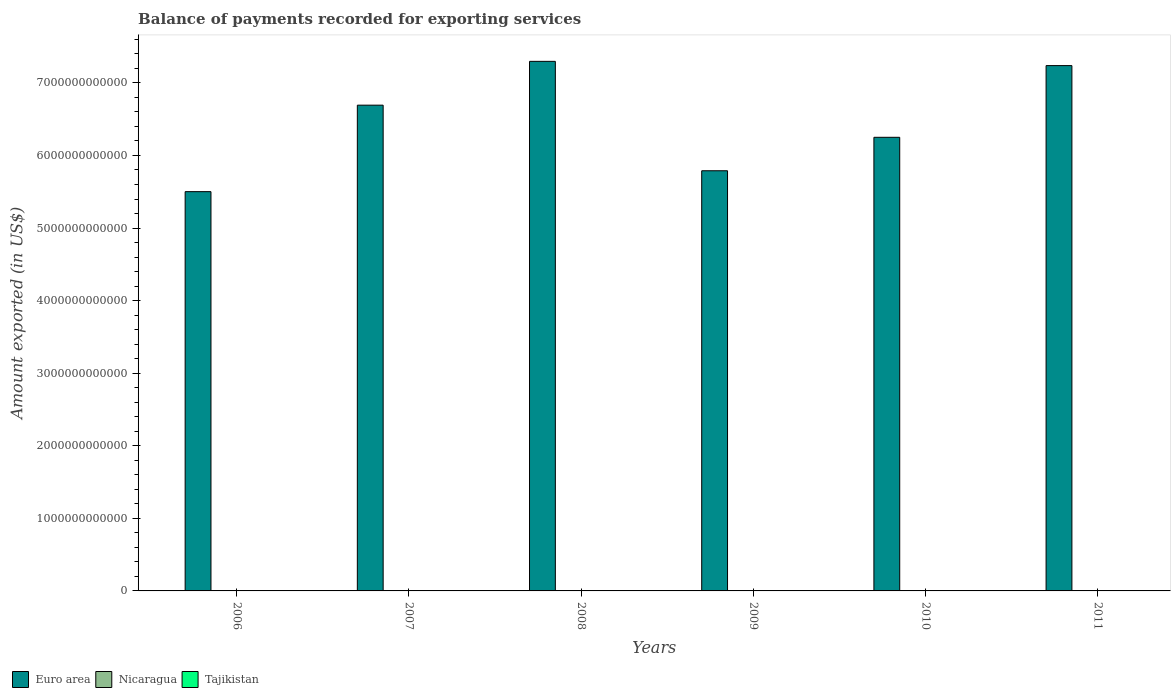How many bars are there on the 3rd tick from the left?
Offer a terse response. 3. How many bars are there on the 4th tick from the right?
Ensure brevity in your answer.  3. What is the label of the 4th group of bars from the left?
Your answer should be compact. 2009. What is the amount exported in Nicaragua in 2007?
Your response must be concise. 2.47e+09. Across all years, what is the maximum amount exported in Nicaragua?
Provide a short and direct response. 4.19e+09. Across all years, what is the minimum amount exported in Nicaragua?
Your response must be concise. 2.10e+09. In which year was the amount exported in Nicaragua maximum?
Your answer should be very brief. 2011. What is the total amount exported in Nicaragua in the graph?
Ensure brevity in your answer.  1.79e+1. What is the difference between the amount exported in Tajikistan in 2006 and that in 2010?
Provide a short and direct response. 7.59e+08. What is the difference between the amount exported in Euro area in 2011 and the amount exported in Tajikistan in 2007?
Give a very brief answer. 7.24e+12. What is the average amount exported in Nicaragua per year?
Provide a succinct answer. 2.98e+09. In the year 2007, what is the difference between the amount exported in Tajikistan and amount exported in Euro area?
Your answer should be compact. -6.69e+12. In how many years, is the amount exported in Nicaragua greater than 3200000000000 US$?
Provide a short and direct response. 0. What is the ratio of the amount exported in Tajikistan in 2006 to that in 2011?
Offer a terse response. 1.38. Is the amount exported in Euro area in 2009 less than that in 2011?
Provide a succinct answer. Yes. What is the difference between the highest and the second highest amount exported in Tajikistan?
Make the answer very short. 4.81e+07. What is the difference between the highest and the lowest amount exported in Tajikistan?
Ensure brevity in your answer.  8.77e+08. Is the sum of the amount exported in Nicaragua in 2007 and 2010 greater than the maximum amount exported in Euro area across all years?
Offer a terse response. No. What does the 2nd bar from the left in 2009 represents?
Offer a very short reply. Nicaragua. What does the 2nd bar from the right in 2010 represents?
Offer a very short reply. Nicaragua. How many bars are there?
Provide a short and direct response. 18. Are all the bars in the graph horizontal?
Ensure brevity in your answer.  No. What is the difference between two consecutive major ticks on the Y-axis?
Your answer should be compact. 1.00e+12. Does the graph contain any zero values?
Your response must be concise. No. Does the graph contain grids?
Provide a short and direct response. No. How many legend labels are there?
Provide a short and direct response. 3. How are the legend labels stacked?
Your answer should be compact. Horizontal. What is the title of the graph?
Your response must be concise. Balance of payments recorded for exporting services. What is the label or title of the X-axis?
Your response must be concise. Years. What is the label or title of the Y-axis?
Give a very brief answer. Amount exported (in US$). What is the Amount exported (in US$) in Euro area in 2006?
Give a very brief answer. 5.50e+12. What is the Amount exported (in US$) in Nicaragua in 2006?
Offer a very short reply. 2.10e+09. What is the Amount exported (in US$) in Tajikistan in 2006?
Make the answer very short. 1.66e+09. What is the Amount exported (in US$) in Euro area in 2007?
Offer a very short reply. 6.69e+12. What is the Amount exported (in US$) of Nicaragua in 2007?
Provide a succinct answer. 2.47e+09. What is the Amount exported (in US$) in Tajikistan in 2007?
Your response must be concise. 1.73e+09. What is the Amount exported (in US$) of Euro area in 2008?
Ensure brevity in your answer.  7.30e+12. What is the Amount exported (in US$) in Nicaragua in 2008?
Keep it short and to the point. 2.88e+09. What is the Amount exported (in US$) of Tajikistan in 2008?
Offer a terse response. 1.78e+09. What is the Amount exported (in US$) of Euro area in 2009?
Keep it short and to the point. 5.79e+12. What is the Amount exported (in US$) of Nicaragua in 2009?
Your answer should be compact. 2.84e+09. What is the Amount exported (in US$) in Tajikistan in 2009?
Provide a succinct answer. 1.23e+09. What is the Amount exported (in US$) in Euro area in 2010?
Offer a terse response. 6.25e+12. What is the Amount exported (in US$) of Nicaragua in 2010?
Give a very brief answer. 3.38e+09. What is the Amount exported (in US$) in Tajikistan in 2010?
Your response must be concise. 8.99e+08. What is the Amount exported (in US$) of Euro area in 2011?
Offer a terse response. 7.24e+12. What is the Amount exported (in US$) in Nicaragua in 2011?
Offer a very short reply. 4.19e+09. What is the Amount exported (in US$) in Tajikistan in 2011?
Your answer should be very brief. 1.20e+09. Across all years, what is the maximum Amount exported (in US$) of Euro area?
Your answer should be compact. 7.30e+12. Across all years, what is the maximum Amount exported (in US$) in Nicaragua?
Keep it short and to the point. 4.19e+09. Across all years, what is the maximum Amount exported (in US$) in Tajikistan?
Give a very brief answer. 1.78e+09. Across all years, what is the minimum Amount exported (in US$) in Euro area?
Offer a terse response. 5.50e+12. Across all years, what is the minimum Amount exported (in US$) in Nicaragua?
Keep it short and to the point. 2.10e+09. Across all years, what is the minimum Amount exported (in US$) in Tajikistan?
Give a very brief answer. 8.99e+08. What is the total Amount exported (in US$) in Euro area in the graph?
Give a very brief answer. 3.88e+13. What is the total Amount exported (in US$) in Nicaragua in the graph?
Your answer should be compact. 1.79e+1. What is the total Amount exported (in US$) of Tajikistan in the graph?
Your answer should be compact. 8.49e+09. What is the difference between the Amount exported (in US$) of Euro area in 2006 and that in 2007?
Provide a succinct answer. -1.19e+12. What is the difference between the Amount exported (in US$) of Nicaragua in 2006 and that in 2007?
Your answer should be compact. -3.72e+08. What is the difference between the Amount exported (in US$) in Tajikistan in 2006 and that in 2007?
Your response must be concise. -6.96e+07. What is the difference between the Amount exported (in US$) of Euro area in 2006 and that in 2008?
Your response must be concise. -1.80e+12. What is the difference between the Amount exported (in US$) in Nicaragua in 2006 and that in 2008?
Your answer should be compact. -7.79e+08. What is the difference between the Amount exported (in US$) of Tajikistan in 2006 and that in 2008?
Keep it short and to the point. -1.18e+08. What is the difference between the Amount exported (in US$) in Euro area in 2006 and that in 2009?
Your answer should be very brief. -2.88e+11. What is the difference between the Amount exported (in US$) of Nicaragua in 2006 and that in 2009?
Provide a short and direct response. -7.42e+08. What is the difference between the Amount exported (in US$) in Tajikistan in 2006 and that in 2009?
Ensure brevity in your answer.  4.33e+08. What is the difference between the Amount exported (in US$) of Euro area in 2006 and that in 2010?
Your response must be concise. -7.49e+11. What is the difference between the Amount exported (in US$) in Nicaragua in 2006 and that in 2010?
Offer a very short reply. -1.28e+09. What is the difference between the Amount exported (in US$) of Tajikistan in 2006 and that in 2010?
Provide a short and direct response. 7.59e+08. What is the difference between the Amount exported (in US$) of Euro area in 2006 and that in 2011?
Your answer should be compact. -1.74e+12. What is the difference between the Amount exported (in US$) in Nicaragua in 2006 and that in 2011?
Offer a very short reply. -2.09e+09. What is the difference between the Amount exported (in US$) in Tajikistan in 2006 and that in 2011?
Ensure brevity in your answer.  4.60e+08. What is the difference between the Amount exported (in US$) of Euro area in 2007 and that in 2008?
Your response must be concise. -6.04e+11. What is the difference between the Amount exported (in US$) of Nicaragua in 2007 and that in 2008?
Provide a short and direct response. -4.07e+08. What is the difference between the Amount exported (in US$) in Tajikistan in 2007 and that in 2008?
Provide a succinct answer. -4.81e+07. What is the difference between the Amount exported (in US$) in Euro area in 2007 and that in 2009?
Make the answer very short. 9.04e+11. What is the difference between the Amount exported (in US$) of Nicaragua in 2007 and that in 2009?
Provide a succinct answer. -3.69e+08. What is the difference between the Amount exported (in US$) in Tajikistan in 2007 and that in 2009?
Ensure brevity in your answer.  5.03e+08. What is the difference between the Amount exported (in US$) of Euro area in 2007 and that in 2010?
Give a very brief answer. 4.43e+11. What is the difference between the Amount exported (in US$) of Nicaragua in 2007 and that in 2010?
Keep it short and to the point. -9.09e+08. What is the difference between the Amount exported (in US$) in Tajikistan in 2007 and that in 2010?
Your response must be concise. 8.29e+08. What is the difference between the Amount exported (in US$) of Euro area in 2007 and that in 2011?
Provide a short and direct response. -5.45e+11. What is the difference between the Amount exported (in US$) of Nicaragua in 2007 and that in 2011?
Provide a short and direct response. -1.72e+09. What is the difference between the Amount exported (in US$) of Tajikistan in 2007 and that in 2011?
Your answer should be compact. 5.30e+08. What is the difference between the Amount exported (in US$) of Euro area in 2008 and that in 2009?
Keep it short and to the point. 1.51e+12. What is the difference between the Amount exported (in US$) of Nicaragua in 2008 and that in 2009?
Ensure brevity in your answer.  3.75e+07. What is the difference between the Amount exported (in US$) in Tajikistan in 2008 and that in 2009?
Offer a very short reply. 5.51e+08. What is the difference between the Amount exported (in US$) of Euro area in 2008 and that in 2010?
Provide a succinct answer. 1.05e+12. What is the difference between the Amount exported (in US$) of Nicaragua in 2008 and that in 2010?
Keep it short and to the point. -5.02e+08. What is the difference between the Amount exported (in US$) of Tajikistan in 2008 and that in 2010?
Your answer should be very brief. 8.77e+08. What is the difference between the Amount exported (in US$) in Euro area in 2008 and that in 2011?
Ensure brevity in your answer.  5.84e+1. What is the difference between the Amount exported (in US$) in Nicaragua in 2008 and that in 2011?
Ensure brevity in your answer.  -1.32e+09. What is the difference between the Amount exported (in US$) of Tajikistan in 2008 and that in 2011?
Provide a succinct answer. 5.78e+08. What is the difference between the Amount exported (in US$) in Euro area in 2009 and that in 2010?
Your response must be concise. -4.61e+11. What is the difference between the Amount exported (in US$) in Nicaragua in 2009 and that in 2010?
Your answer should be very brief. -5.40e+08. What is the difference between the Amount exported (in US$) of Tajikistan in 2009 and that in 2010?
Your answer should be very brief. 3.26e+08. What is the difference between the Amount exported (in US$) in Euro area in 2009 and that in 2011?
Provide a short and direct response. -1.45e+12. What is the difference between the Amount exported (in US$) of Nicaragua in 2009 and that in 2011?
Your answer should be very brief. -1.35e+09. What is the difference between the Amount exported (in US$) of Tajikistan in 2009 and that in 2011?
Offer a very short reply. 2.75e+07. What is the difference between the Amount exported (in US$) in Euro area in 2010 and that in 2011?
Provide a succinct answer. -9.88e+11. What is the difference between the Amount exported (in US$) of Nicaragua in 2010 and that in 2011?
Provide a short and direct response. -8.13e+08. What is the difference between the Amount exported (in US$) in Tajikistan in 2010 and that in 2011?
Keep it short and to the point. -2.99e+08. What is the difference between the Amount exported (in US$) of Euro area in 2006 and the Amount exported (in US$) of Nicaragua in 2007?
Provide a succinct answer. 5.50e+12. What is the difference between the Amount exported (in US$) in Euro area in 2006 and the Amount exported (in US$) in Tajikistan in 2007?
Make the answer very short. 5.50e+12. What is the difference between the Amount exported (in US$) of Nicaragua in 2006 and the Amount exported (in US$) of Tajikistan in 2007?
Keep it short and to the point. 3.69e+08. What is the difference between the Amount exported (in US$) of Euro area in 2006 and the Amount exported (in US$) of Nicaragua in 2008?
Your response must be concise. 5.50e+12. What is the difference between the Amount exported (in US$) in Euro area in 2006 and the Amount exported (in US$) in Tajikistan in 2008?
Offer a terse response. 5.50e+12. What is the difference between the Amount exported (in US$) in Nicaragua in 2006 and the Amount exported (in US$) in Tajikistan in 2008?
Your answer should be very brief. 3.20e+08. What is the difference between the Amount exported (in US$) of Euro area in 2006 and the Amount exported (in US$) of Nicaragua in 2009?
Provide a succinct answer. 5.50e+12. What is the difference between the Amount exported (in US$) in Euro area in 2006 and the Amount exported (in US$) in Tajikistan in 2009?
Your answer should be compact. 5.50e+12. What is the difference between the Amount exported (in US$) of Nicaragua in 2006 and the Amount exported (in US$) of Tajikistan in 2009?
Offer a very short reply. 8.71e+08. What is the difference between the Amount exported (in US$) in Euro area in 2006 and the Amount exported (in US$) in Nicaragua in 2010?
Offer a terse response. 5.50e+12. What is the difference between the Amount exported (in US$) of Euro area in 2006 and the Amount exported (in US$) of Tajikistan in 2010?
Your answer should be compact. 5.50e+12. What is the difference between the Amount exported (in US$) of Nicaragua in 2006 and the Amount exported (in US$) of Tajikistan in 2010?
Give a very brief answer. 1.20e+09. What is the difference between the Amount exported (in US$) of Euro area in 2006 and the Amount exported (in US$) of Nicaragua in 2011?
Make the answer very short. 5.50e+12. What is the difference between the Amount exported (in US$) in Euro area in 2006 and the Amount exported (in US$) in Tajikistan in 2011?
Offer a terse response. 5.50e+12. What is the difference between the Amount exported (in US$) of Nicaragua in 2006 and the Amount exported (in US$) of Tajikistan in 2011?
Provide a succinct answer. 8.99e+08. What is the difference between the Amount exported (in US$) in Euro area in 2007 and the Amount exported (in US$) in Nicaragua in 2008?
Provide a succinct answer. 6.69e+12. What is the difference between the Amount exported (in US$) in Euro area in 2007 and the Amount exported (in US$) in Tajikistan in 2008?
Keep it short and to the point. 6.69e+12. What is the difference between the Amount exported (in US$) of Nicaragua in 2007 and the Amount exported (in US$) of Tajikistan in 2008?
Keep it short and to the point. 6.93e+08. What is the difference between the Amount exported (in US$) in Euro area in 2007 and the Amount exported (in US$) in Nicaragua in 2009?
Keep it short and to the point. 6.69e+12. What is the difference between the Amount exported (in US$) of Euro area in 2007 and the Amount exported (in US$) of Tajikistan in 2009?
Provide a succinct answer. 6.69e+12. What is the difference between the Amount exported (in US$) in Nicaragua in 2007 and the Amount exported (in US$) in Tajikistan in 2009?
Your answer should be very brief. 1.24e+09. What is the difference between the Amount exported (in US$) in Euro area in 2007 and the Amount exported (in US$) in Nicaragua in 2010?
Your answer should be very brief. 6.69e+12. What is the difference between the Amount exported (in US$) in Euro area in 2007 and the Amount exported (in US$) in Tajikistan in 2010?
Ensure brevity in your answer.  6.69e+12. What is the difference between the Amount exported (in US$) in Nicaragua in 2007 and the Amount exported (in US$) in Tajikistan in 2010?
Make the answer very short. 1.57e+09. What is the difference between the Amount exported (in US$) of Euro area in 2007 and the Amount exported (in US$) of Nicaragua in 2011?
Keep it short and to the point. 6.69e+12. What is the difference between the Amount exported (in US$) in Euro area in 2007 and the Amount exported (in US$) in Tajikistan in 2011?
Offer a very short reply. 6.69e+12. What is the difference between the Amount exported (in US$) of Nicaragua in 2007 and the Amount exported (in US$) of Tajikistan in 2011?
Your response must be concise. 1.27e+09. What is the difference between the Amount exported (in US$) of Euro area in 2008 and the Amount exported (in US$) of Nicaragua in 2009?
Your response must be concise. 7.29e+12. What is the difference between the Amount exported (in US$) in Euro area in 2008 and the Amount exported (in US$) in Tajikistan in 2009?
Provide a short and direct response. 7.30e+12. What is the difference between the Amount exported (in US$) in Nicaragua in 2008 and the Amount exported (in US$) in Tajikistan in 2009?
Provide a short and direct response. 1.65e+09. What is the difference between the Amount exported (in US$) in Euro area in 2008 and the Amount exported (in US$) in Nicaragua in 2010?
Provide a succinct answer. 7.29e+12. What is the difference between the Amount exported (in US$) in Euro area in 2008 and the Amount exported (in US$) in Tajikistan in 2010?
Give a very brief answer. 7.30e+12. What is the difference between the Amount exported (in US$) in Nicaragua in 2008 and the Amount exported (in US$) in Tajikistan in 2010?
Provide a succinct answer. 1.98e+09. What is the difference between the Amount exported (in US$) of Euro area in 2008 and the Amount exported (in US$) of Nicaragua in 2011?
Offer a very short reply. 7.29e+12. What is the difference between the Amount exported (in US$) in Euro area in 2008 and the Amount exported (in US$) in Tajikistan in 2011?
Your answer should be compact. 7.30e+12. What is the difference between the Amount exported (in US$) of Nicaragua in 2008 and the Amount exported (in US$) of Tajikistan in 2011?
Offer a very short reply. 1.68e+09. What is the difference between the Amount exported (in US$) in Euro area in 2009 and the Amount exported (in US$) in Nicaragua in 2010?
Ensure brevity in your answer.  5.79e+12. What is the difference between the Amount exported (in US$) of Euro area in 2009 and the Amount exported (in US$) of Tajikistan in 2010?
Keep it short and to the point. 5.79e+12. What is the difference between the Amount exported (in US$) in Nicaragua in 2009 and the Amount exported (in US$) in Tajikistan in 2010?
Make the answer very short. 1.94e+09. What is the difference between the Amount exported (in US$) in Euro area in 2009 and the Amount exported (in US$) in Nicaragua in 2011?
Give a very brief answer. 5.79e+12. What is the difference between the Amount exported (in US$) in Euro area in 2009 and the Amount exported (in US$) in Tajikistan in 2011?
Offer a terse response. 5.79e+12. What is the difference between the Amount exported (in US$) of Nicaragua in 2009 and the Amount exported (in US$) of Tajikistan in 2011?
Ensure brevity in your answer.  1.64e+09. What is the difference between the Amount exported (in US$) of Euro area in 2010 and the Amount exported (in US$) of Nicaragua in 2011?
Your answer should be very brief. 6.25e+12. What is the difference between the Amount exported (in US$) of Euro area in 2010 and the Amount exported (in US$) of Tajikistan in 2011?
Your response must be concise. 6.25e+12. What is the difference between the Amount exported (in US$) in Nicaragua in 2010 and the Amount exported (in US$) in Tajikistan in 2011?
Ensure brevity in your answer.  2.18e+09. What is the average Amount exported (in US$) of Euro area per year?
Provide a succinct answer. 6.46e+12. What is the average Amount exported (in US$) in Nicaragua per year?
Your answer should be compact. 2.98e+09. What is the average Amount exported (in US$) of Tajikistan per year?
Give a very brief answer. 1.41e+09. In the year 2006, what is the difference between the Amount exported (in US$) in Euro area and Amount exported (in US$) in Nicaragua?
Your response must be concise. 5.50e+12. In the year 2006, what is the difference between the Amount exported (in US$) of Euro area and Amount exported (in US$) of Tajikistan?
Provide a short and direct response. 5.50e+12. In the year 2006, what is the difference between the Amount exported (in US$) in Nicaragua and Amount exported (in US$) in Tajikistan?
Provide a succinct answer. 4.38e+08. In the year 2007, what is the difference between the Amount exported (in US$) in Euro area and Amount exported (in US$) in Nicaragua?
Provide a short and direct response. 6.69e+12. In the year 2007, what is the difference between the Amount exported (in US$) of Euro area and Amount exported (in US$) of Tajikistan?
Provide a short and direct response. 6.69e+12. In the year 2007, what is the difference between the Amount exported (in US$) in Nicaragua and Amount exported (in US$) in Tajikistan?
Offer a terse response. 7.41e+08. In the year 2008, what is the difference between the Amount exported (in US$) of Euro area and Amount exported (in US$) of Nicaragua?
Ensure brevity in your answer.  7.29e+12. In the year 2008, what is the difference between the Amount exported (in US$) in Euro area and Amount exported (in US$) in Tajikistan?
Give a very brief answer. 7.30e+12. In the year 2008, what is the difference between the Amount exported (in US$) in Nicaragua and Amount exported (in US$) in Tajikistan?
Provide a short and direct response. 1.10e+09. In the year 2009, what is the difference between the Amount exported (in US$) of Euro area and Amount exported (in US$) of Nicaragua?
Give a very brief answer. 5.79e+12. In the year 2009, what is the difference between the Amount exported (in US$) in Euro area and Amount exported (in US$) in Tajikistan?
Your answer should be compact. 5.79e+12. In the year 2009, what is the difference between the Amount exported (in US$) of Nicaragua and Amount exported (in US$) of Tajikistan?
Offer a very short reply. 1.61e+09. In the year 2010, what is the difference between the Amount exported (in US$) in Euro area and Amount exported (in US$) in Nicaragua?
Provide a succinct answer. 6.25e+12. In the year 2010, what is the difference between the Amount exported (in US$) of Euro area and Amount exported (in US$) of Tajikistan?
Make the answer very short. 6.25e+12. In the year 2010, what is the difference between the Amount exported (in US$) in Nicaragua and Amount exported (in US$) in Tajikistan?
Make the answer very short. 2.48e+09. In the year 2011, what is the difference between the Amount exported (in US$) in Euro area and Amount exported (in US$) in Nicaragua?
Provide a succinct answer. 7.23e+12. In the year 2011, what is the difference between the Amount exported (in US$) in Euro area and Amount exported (in US$) in Tajikistan?
Ensure brevity in your answer.  7.24e+12. In the year 2011, what is the difference between the Amount exported (in US$) in Nicaragua and Amount exported (in US$) in Tajikistan?
Offer a terse response. 2.99e+09. What is the ratio of the Amount exported (in US$) in Euro area in 2006 to that in 2007?
Ensure brevity in your answer.  0.82. What is the ratio of the Amount exported (in US$) in Nicaragua in 2006 to that in 2007?
Your response must be concise. 0.85. What is the ratio of the Amount exported (in US$) in Tajikistan in 2006 to that in 2007?
Your answer should be very brief. 0.96. What is the ratio of the Amount exported (in US$) of Euro area in 2006 to that in 2008?
Your answer should be compact. 0.75. What is the ratio of the Amount exported (in US$) in Nicaragua in 2006 to that in 2008?
Offer a very short reply. 0.73. What is the ratio of the Amount exported (in US$) in Tajikistan in 2006 to that in 2008?
Make the answer very short. 0.93. What is the ratio of the Amount exported (in US$) in Euro area in 2006 to that in 2009?
Your response must be concise. 0.95. What is the ratio of the Amount exported (in US$) of Nicaragua in 2006 to that in 2009?
Provide a succinct answer. 0.74. What is the ratio of the Amount exported (in US$) of Tajikistan in 2006 to that in 2009?
Offer a very short reply. 1.35. What is the ratio of the Amount exported (in US$) in Euro area in 2006 to that in 2010?
Your response must be concise. 0.88. What is the ratio of the Amount exported (in US$) of Nicaragua in 2006 to that in 2010?
Your answer should be compact. 0.62. What is the ratio of the Amount exported (in US$) of Tajikistan in 2006 to that in 2010?
Provide a short and direct response. 1.84. What is the ratio of the Amount exported (in US$) of Euro area in 2006 to that in 2011?
Provide a short and direct response. 0.76. What is the ratio of the Amount exported (in US$) of Nicaragua in 2006 to that in 2011?
Your answer should be compact. 0.5. What is the ratio of the Amount exported (in US$) in Tajikistan in 2006 to that in 2011?
Offer a very short reply. 1.38. What is the ratio of the Amount exported (in US$) in Euro area in 2007 to that in 2008?
Offer a very short reply. 0.92. What is the ratio of the Amount exported (in US$) in Nicaragua in 2007 to that in 2008?
Offer a terse response. 0.86. What is the ratio of the Amount exported (in US$) in Tajikistan in 2007 to that in 2008?
Provide a succinct answer. 0.97. What is the ratio of the Amount exported (in US$) of Euro area in 2007 to that in 2009?
Your answer should be very brief. 1.16. What is the ratio of the Amount exported (in US$) in Nicaragua in 2007 to that in 2009?
Keep it short and to the point. 0.87. What is the ratio of the Amount exported (in US$) of Tajikistan in 2007 to that in 2009?
Your answer should be compact. 1.41. What is the ratio of the Amount exported (in US$) in Euro area in 2007 to that in 2010?
Make the answer very short. 1.07. What is the ratio of the Amount exported (in US$) of Nicaragua in 2007 to that in 2010?
Give a very brief answer. 0.73. What is the ratio of the Amount exported (in US$) of Tajikistan in 2007 to that in 2010?
Provide a short and direct response. 1.92. What is the ratio of the Amount exported (in US$) of Euro area in 2007 to that in 2011?
Your answer should be very brief. 0.92. What is the ratio of the Amount exported (in US$) of Nicaragua in 2007 to that in 2011?
Ensure brevity in your answer.  0.59. What is the ratio of the Amount exported (in US$) of Tajikistan in 2007 to that in 2011?
Your answer should be compact. 1.44. What is the ratio of the Amount exported (in US$) of Euro area in 2008 to that in 2009?
Make the answer very short. 1.26. What is the ratio of the Amount exported (in US$) of Nicaragua in 2008 to that in 2009?
Provide a succinct answer. 1.01. What is the ratio of the Amount exported (in US$) of Tajikistan in 2008 to that in 2009?
Offer a terse response. 1.45. What is the ratio of the Amount exported (in US$) in Euro area in 2008 to that in 2010?
Make the answer very short. 1.17. What is the ratio of the Amount exported (in US$) of Nicaragua in 2008 to that in 2010?
Your answer should be compact. 0.85. What is the ratio of the Amount exported (in US$) in Tajikistan in 2008 to that in 2010?
Provide a short and direct response. 1.98. What is the ratio of the Amount exported (in US$) of Euro area in 2008 to that in 2011?
Your response must be concise. 1.01. What is the ratio of the Amount exported (in US$) of Nicaragua in 2008 to that in 2011?
Provide a succinct answer. 0.69. What is the ratio of the Amount exported (in US$) in Tajikistan in 2008 to that in 2011?
Offer a very short reply. 1.48. What is the ratio of the Amount exported (in US$) of Euro area in 2009 to that in 2010?
Offer a very short reply. 0.93. What is the ratio of the Amount exported (in US$) of Nicaragua in 2009 to that in 2010?
Your answer should be very brief. 0.84. What is the ratio of the Amount exported (in US$) in Tajikistan in 2009 to that in 2010?
Your response must be concise. 1.36. What is the ratio of the Amount exported (in US$) of Euro area in 2009 to that in 2011?
Ensure brevity in your answer.  0.8. What is the ratio of the Amount exported (in US$) in Nicaragua in 2009 to that in 2011?
Ensure brevity in your answer.  0.68. What is the ratio of the Amount exported (in US$) in Tajikistan in 2009 to that in 2011?
Your response must be concise. 1.02. What is the ratio of the Amount exported (in US$) of Euro area in 2010 to that in 2011?
Offer a terse response. 0.86. What is the ratio of the Amount exported (in US$) in Nicaragua in 2010 to that in 2011?
Provide a short and direct response. 0.81. What is the ratio of the Amount exported (in US$) of Tajikistan in 2010 to that in 2011?
Provide a short and direct response. 0.75. What is the difference between the highest and the second highest Amount exported (in US$) in Euro area?
Your answer should be very brief. 5.84e+1. What is the difference between the highest and the second highest Amount exported (in US$) in Nicaragua?
Give a very brief answer. 8.13e+08. What is the difference between the highest and the second highest Amount exported (in US$) in Tajikistan?
Ensure brevity in your answer.  4.81e+07. What is the difference between the highest and the lowest Amount exported (in US$) in Euro area?
Offer a very short reply. 1.80e+12. What is the difference between the highest and the lowest Amount exported (in US$) in Nicaragua?
Your response must be concise. 2.09e+09. What is the difference between the highest and the lowest Amount exported (in US$) of Tajikistan?
Make the answer very short. 8.77e+08. 